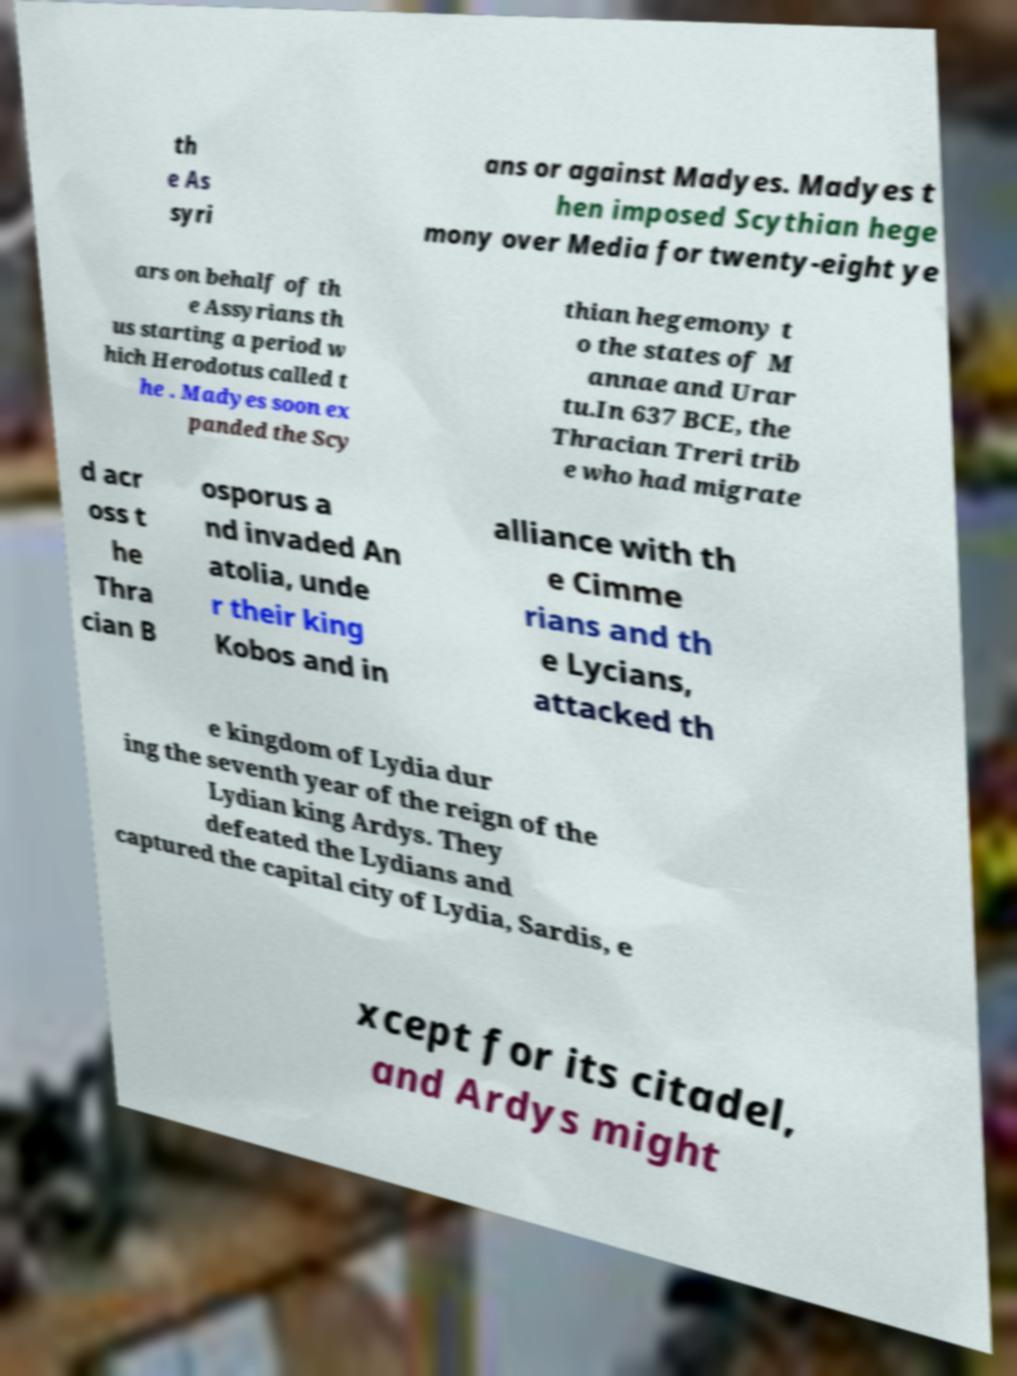Could you assist in decoding the text presented in this image and type it out clearly? th e As syri ans or against Madyes. Madyes t hen imposed Scythian hege mony over Media for twenty-eight ye ars on behalf of th e Assyrians th us starting a period w hich Herodotus called t he . Madyes soon ex panded the Scy thian hegemony t o the states of M annae and Urar tu.In 637 BCE, the Thracian Treri trib e who had migrate d acr oss t he Thra cian B osporus a nd invaded An atolia, unde r their king Kobos and in alliance with th e Cimme rians and th e Lycians, attacked th e kingdom of Lydia dur ing the seventh year of the reign of the Lydian king Ardys. They defeated the Lydians and captured the capital city of Lydia, Sardis, e xcept for its citadel, and Ardys might 